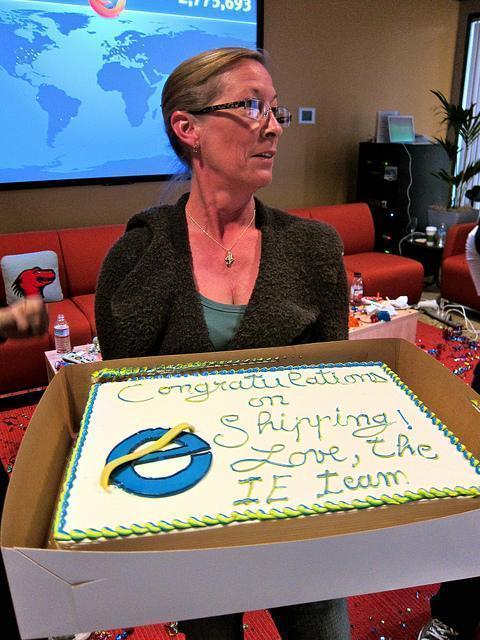Where is this cake and woman located?
Indicate the correct choice and explain in the format: 'Answer: answer
Rationale: rationale.'
Options: Tech office, child's home, zoo, family home. Answer: tech office.
Rationale: A lot of equipment is around her. 